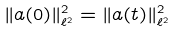<formula> <loc_0><loc_0><loc_500><loc_500>\| a ( 0 ) \| ^ { 2 } _ { \ell ^ { 2 } } = \| a ( t ) \| ^ { 2 } _ { \ell ^ { 2 } }</formula> 